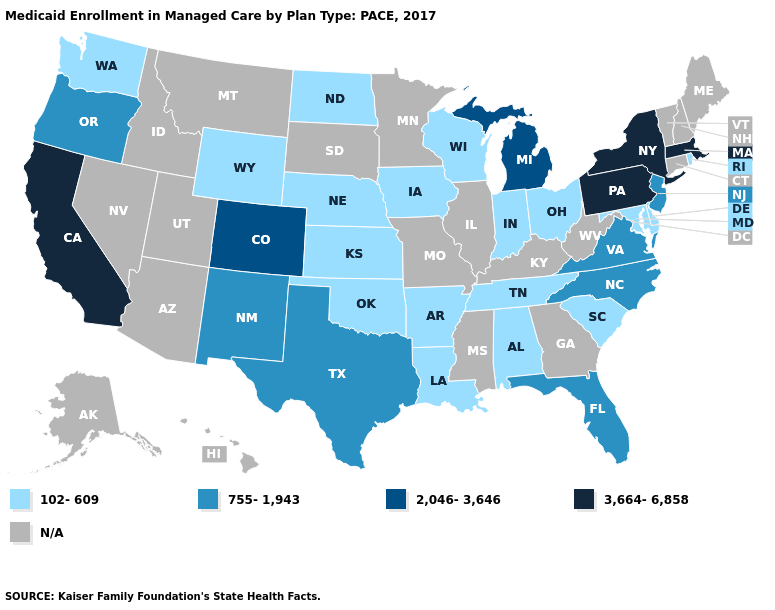Which states have the lowest value in the MidWest?
Be succinct. Indiana, Iowa, Kansas, Nebraska, North Dakota, Ohio, Wisconsin. What is the highest value in states that border Tennessee?
Concise answer only. 755-1,943. What is the value of Wisconsin?
Concise answer only. 102-609. What is the value of California?
Concise answer only. 3,664-6,858. What is the highest value in the USA?
Give a very brief answer. 3,664-6,858. Among the states that border New Jersey , which have the lowest value?
Give a very brief answer. Delaware. Does Wisconsin have the lowest value in the USA?
Concise answer only. Yes. What is the lowest value in the USA?
Concise answer only. 102-609. Name the states that have a value in the range 3,664-6,858?
Write a very short answer. California, Massachusetts, New York, Pennsylvania. Does the first symbol in the legend represent the smallest category?
Short answer required. Yes. Which states have the highest value in the USA?
Short answer required. California, Massachusetts, New York, Pennsylvania. Name the states that have a value in the range N/A?
Write a very short answer. Alaska, Arizona, Connecticut, Georgia, Hawaii, Idaho, Illinois, Kentucky, Maine, Minnesota, Mississippi, Missouri, Montana, Nevada, New Hampshire, South Dakota, Utah, Vermont, West Virginia. Is the legend a continuous bar?
Answer briefly. No. Name the states that have a value in the range 102-609?
Write a very short answer. Alabama, Arkansas, Delaware, Indiana, Iowa, Kansas, Louisiana, Maryland, Nebraska, North Dakota, Ohio, Oklahoma, Rhode Island, South Carolina, Tennessee, Washington, Wisconsin, Wyoming. 